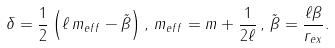<formula> <loc_0><loc_0><loc_500><loc_500>\delta = \frac { 1 } { 2 } \left ( \ell \, m _ { e f f } - \tilde { \beta } \right ) , \, m _ { e f f } = m + \frac { 1 } { 2 \ell } \, , \, \tilde { \beta } = \frac { \ell \beta } { r _ { e x } } .</formula> 